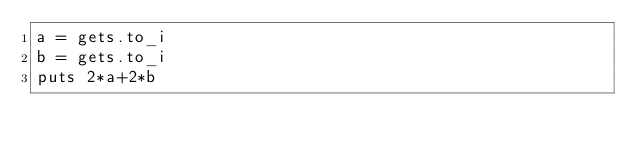Convert code to text. <code><loc_0><loc_0><loc_500><loc_500><_Ruby_>a = gets.to_i
b = gets.to_i
puts 2*a+2*b</code> 